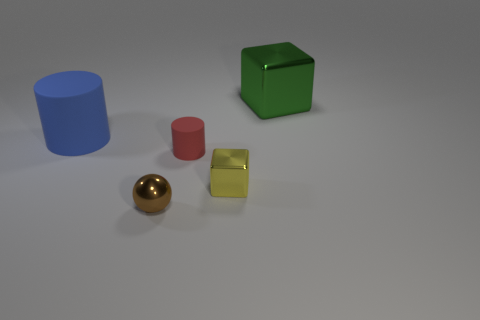Subtract all red cylinders. How many cylinders are left? 1 Add 4 purple cubes. How many objects exist? 9 Subtract all gray cubes. Subtract all cyan balls. How many cubes are left? 2 Subtract all small red rubber things. Subtract all small yellow metal cubes. How many objects are left? 3 Add 5 blocks. How many blocks are left? 7 Add 4 tiny brown cylinders. How many tiny brown cylinders exist? 4 Subtract 0 cyan cubes. How many objects are left? 5 Subtract all blocks. How many objects are left? 3 